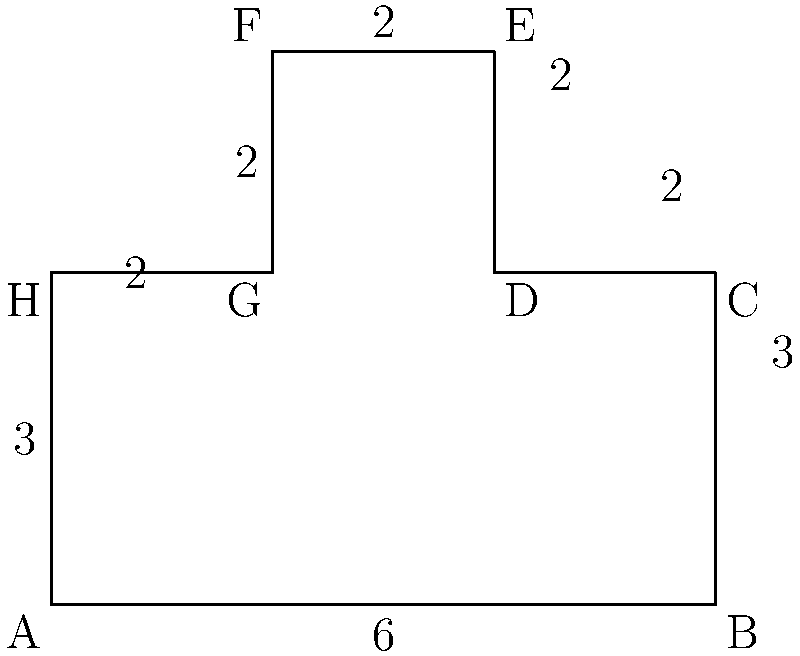As part of your fraternity initiation, you're tasked with calculating the perimeter of the irregularly-shaped fraternity lawn shown above. The lawn's dimensions are given in yards. What is the total perimeter of the lawn in yards? To find the perimeter of the irregularly-shaped lawn, we need to sum up the lengths of all sides:

1. Side AB: 6 yards
2. Side BC: 3 yards
3. Side CD: 2 yards
4. Side DE: 2 yards
5. Side EF: 2 yards
6. Side FG: 2 yards
7. Side GH: 2 yards
8. Side HA: 3 yards

Now, let's add all these lengths:

$$6 + 3 + 2 + 2 + 2 + 2 + 2 + 3 = 22$$

Therefore, the total perimeter of the fraternity lawn is 22 yards.
Answer: 22 yards 